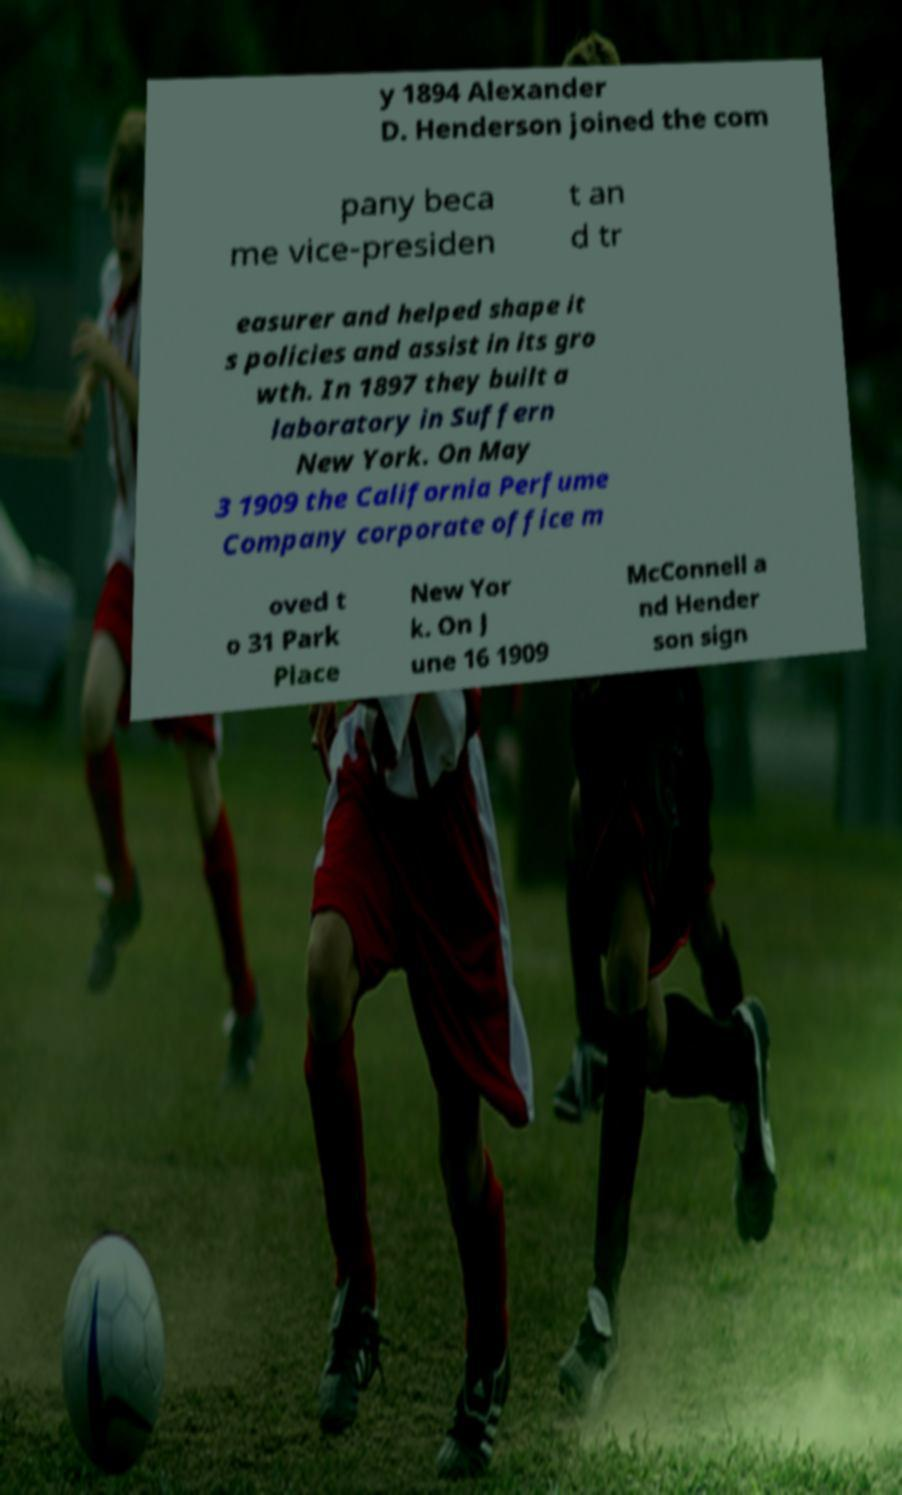Could you assist in decoding the text presented in this image and type it out clearly? y 1894 Alexander D. Henderson joined the com pany beca me vice-presiden t an d tr easurer and helped shape it s policies and assist in its gro wth. In 1897 they built a laboratory in Suffern New York. On May 3 1909 the California Perfume Company corporate office m oved t o 31 Park Place New Yor k. On J une 16 1909 McConnell a nd Hender son sign 